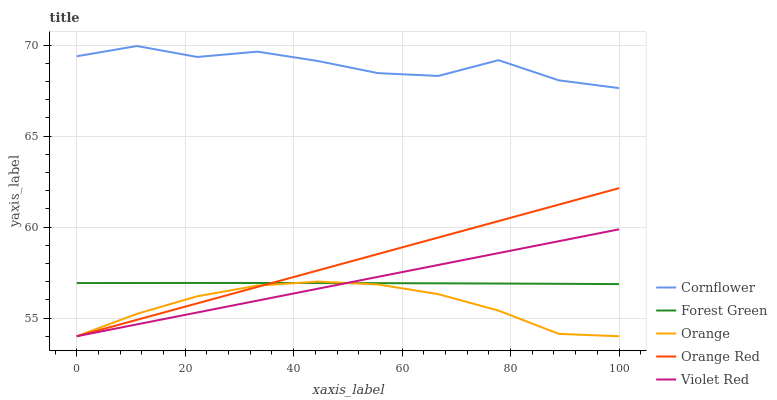Does Orange have the minimum area under the curve?
Answer yes or no. Yes. Does Cornflower have the maximum area under the curve?
Answer yes or no. Yes. Does Forest Green have the minimum area under the curve?
Answer yes or no. No. Does Forest Green have the maximum area under the curve?
Answer yes or no. No. Is Violet Red the smoothest?
Answer yes or no. Yes. Is Cornflower the roughest?
Answer yes or no. Yes. Is Forest Green the smoothest?
Answer yes or no. No. Is Forest Green the roughest?
Answer yes or no. No. Does Forest Green have the lowest value?
Answer yes or no. No. Does Forest Green have the highest value?
Answer yes or no. No. Is Forest Green less than Cornflower?
Answer yes or no. Yes. Is Cornflower greater than Violet Red?
Answer yes or no. Yes. Does Forest Green intersect Cornflower?
Answer yes or no. No. 